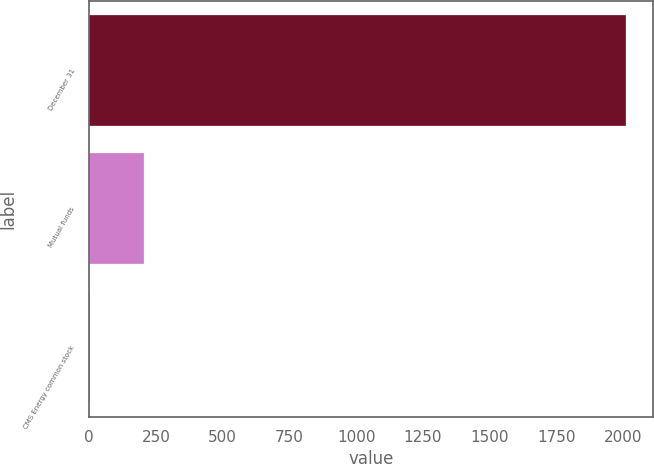Convert chart. <chart><loc_0><loc_0><loc_500><loc_500><bar_chart><fcel>December 31<fcel>Mutual funds<fcel>CMS Energy common stock<nl><fcel>2012<fcel>203.9<fcel>3<nl></chart> 